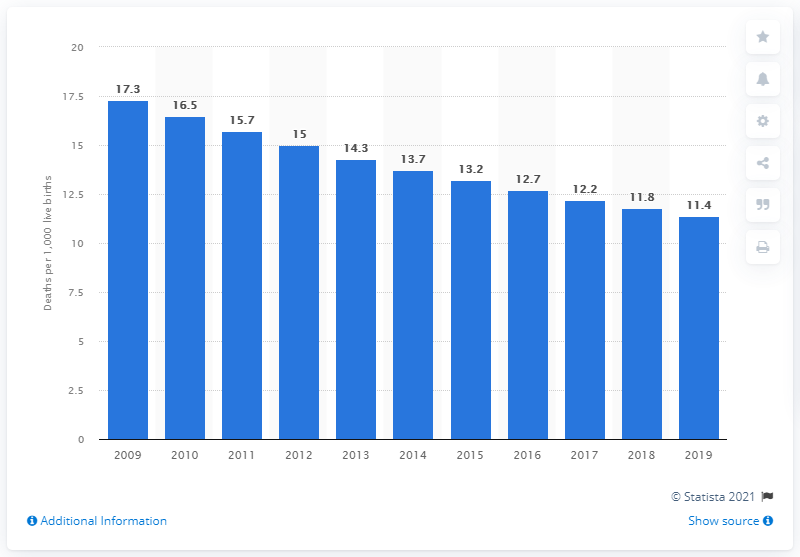Give some essential details in this illustration. In 2019, the infant mortality rate in El Salvador was 11.4 deaths per 1,000 live births. 